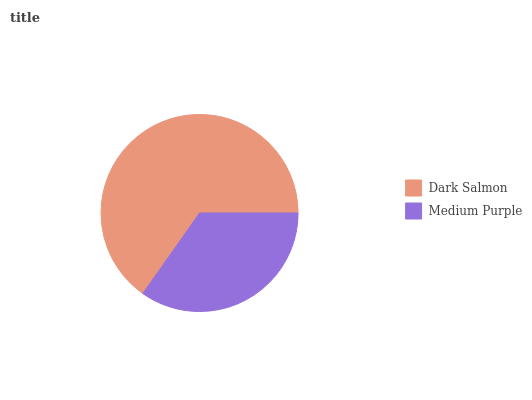Is Medium Purple the minimum?
Answer yes or no. Yes. Is Dark Salmon the maximum?
Answer yes or no. Yes. Is Medium Purple the maximum?
Answer yes or no. No. Is Dark Salmon greater than Medium Purple?
Answer yes or no. Yes. Is Medium Purple less than Dark Salmon?
Answer yes or no. Yes. Is Medium Purple greater than Dark Salmon?
Answer yes or no. No. Is Dark Salmon less than Medium Purple?
Answer yes or no. No. Is Dark Salmon the high median?
Answer yes or no. Yes. Is Medium Purple the low median?
Answer yes or no. Yes. Is Medium Purple the high median?
Answer yes or no. No. Is Dark Salmon the low median?
Answer yes or no. No. 